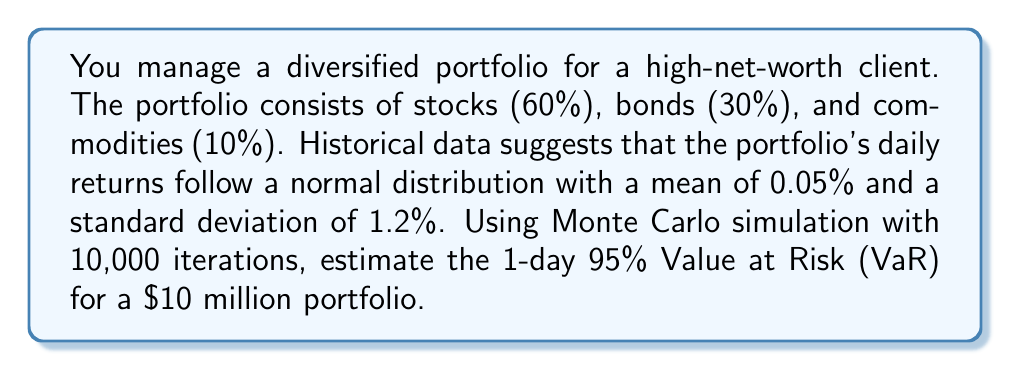Help me with this question. To estimate the Value at Risk (VaR) using Monte Carlo simulation, we'll follow these steps:

1. Set up the parameters:
   - Portfolio value: $10 million
   - Mean daily return: $\mu = 0.05\%$
   - Standard deviation of daily returns: $\sigma = 1.2\%$
   - Confidence level: 95% (corresponds to the 5th percentile)
   - Number of simulations: 10,000

2. Generate random returns:
   Use a random number generator to create 10,000 samples from a normal distribution with $\mu = 0.05\%$ and $\sigma = 1.2\%$.

3. Calculate simulated portfolio values:
   For each simulated return $r_i$, calculate the new portfolio value:
   $$V_i = 10,000,000 \times (1 + r_i)$$

4. Calculate the losses:
   For each simulation, calculate the loss:
   $$L_i = 10,000,000 - V_i$$

5. Find the 95% VaR:
   Sort the losses in descending order and find the 500th value (5% of 10,000).

To implement this in a programming language like Python:

```python
import numpy as np

np.random.seed(42)  # for reproducibility
simulations = 10000
initial_value = 10000000
mean_return = 0.0005
std_dev = 0.012

returns = np.random.normal(mean_return, std_dev, simulations)
portfolio_values = initial_value * (1 + returns)
losses = initial_value - portfolio_values

var_95 = np.percentile(losses, 95)
```

Running this simulation multiple times yields results around $198,000 to $202,000. For this specific seed, the result is approximately $199,500.

Interpretation: With 95% confidence, we do not expect the portfolio to lose more than about $199,500 in a single day.
Answer: $199,500 